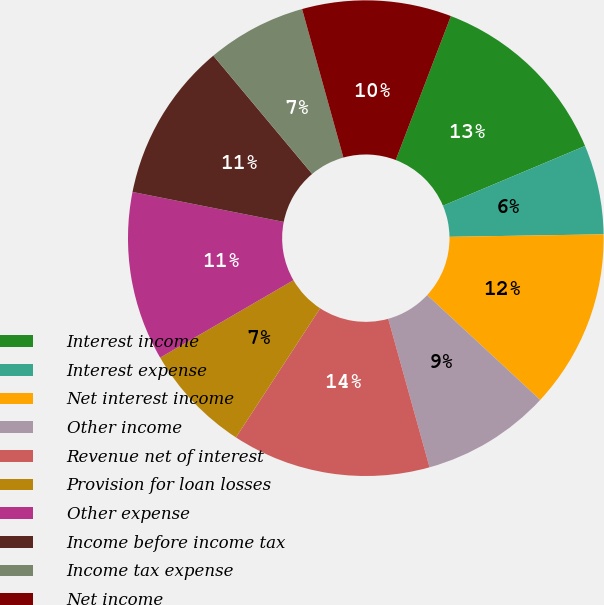Convert chart to OTSL. <chart><loc_0><loc_0><loc_500><loc_500><pie_chart><fcel>Interest income<fcel>Interest expense<fcel>Net interest income<fcel>Other income<fcel>Revenue net of interest<fcel>Provision for loan losses<fcel>Other expense<fcel>Income before income tax<fcel>Income tax expense<fcel>Net income<nl><fcel>12.84%<fcel>6.08%<fcel>12.16%<fcel>8.78%<fcel>13.51%<fcel>7.43%<fcel>11.49%<fcel>10.81%<fcel>6.76%<fcel>10.14%<nl></chart> 